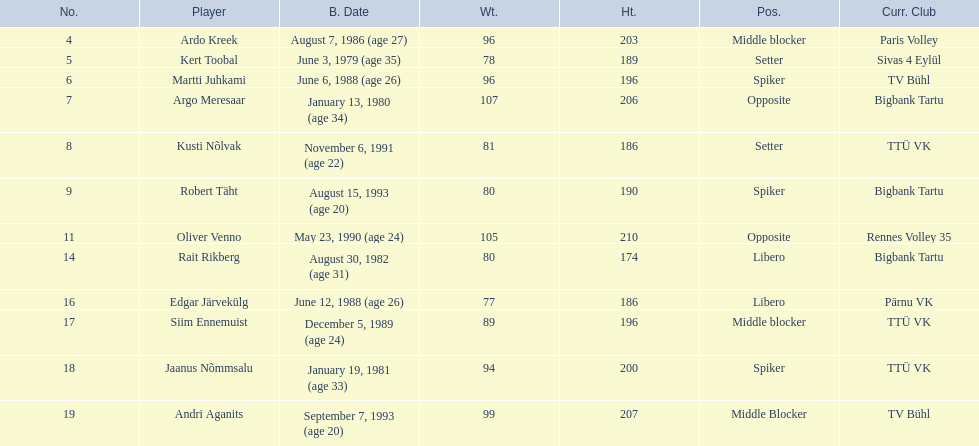What are the total number of players from france? 2. 